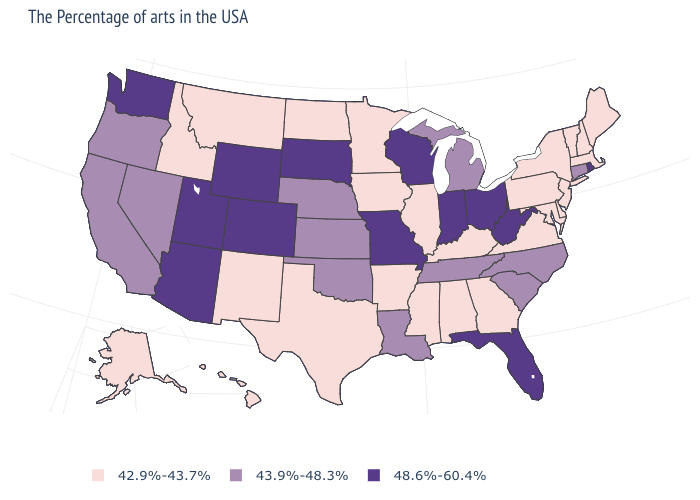Which states have the lowest value in the MidWest?
Short answer required. Illinois, Minnesota, Iowa, North Dakota. Name the states that have a value in the range 42.9%-43.7%?
Be succinct. Maine, Massachusetts, New Hampshire, Vermont, New York, New Jersey, Delaware, Maryland, Pennsylvania, Virginia, Georgia, Kentucky, Alabama, Illinois, Mississippi, Arkansas, Minnesota, Iowa, Texas, North Dakota, New Mexico, Montana, Idaho, Alaska, Hawaii. Is the legend a continuous bar?
Give a very brief answer. No. Does Alaska have the lowest value in the West?
Give a very brief answer. Yes. Among the states that border Georgia , which have the lowest value?
Answer briefly. Alabama. How many symbols are there in the legend?
Give a very brief answer. 3. Name the states that have a value in the range 48.6%-60.4%?
Be succinct. Rhode Island, West Virginia, Ohio, Florida, Indiana, Wisconsin, Missouri, South Dakota, Wyoming, Colorado, Utah, Arizona, Washington. Among the states that border Idaho , does Utah have the highest value?
Give a very brief answer. Yes. Name the states that have a value in the range 42.9%-43.7%?
Answer briefly. Maine, Massachusetts, New Hampshire, Vermont, New York, New Jersey, Delaware, Maryland, Pennsylvania, Virginia, Georgia, Kentucky, Alabama, Illinois, Mississippi, Arkansas, Minnesota, Iowa, Texas, North Dakota, New Mexico, Montana, Idaho, Alaska, Hawaii. What is the value of Florida?
Answer briefly. 48.6%-60.4%. What is the value of Massachusetts?
Write a very short answer. 42.9%-43.7%. Name the states that have a value in the range 43.9%-48.3%?
Write a very short answer. Connecticut, North Carolina, South Carolina, Michigan, Tennessee, Louisiana, Kansas, Nebraska, Oklahoma, Nevada, California, Oregon. Name the states that have a value in the range 48.6%-60.4%?
Write a very short answer. Rhode Island, West Virginia, Ohio, Florida, Indiana, Wisconsin, Missouri, South Dakota, Wyoming, Colorado, Utah, Arizona, Washington. Among the states that border Indiana , does Ohio have the highest value?
Write a very short answer. Yes. Among the states that border Missouri , which have the lowest value?
Answer briefly. Kentucky, Illinois, Arkansas, Iowa. 